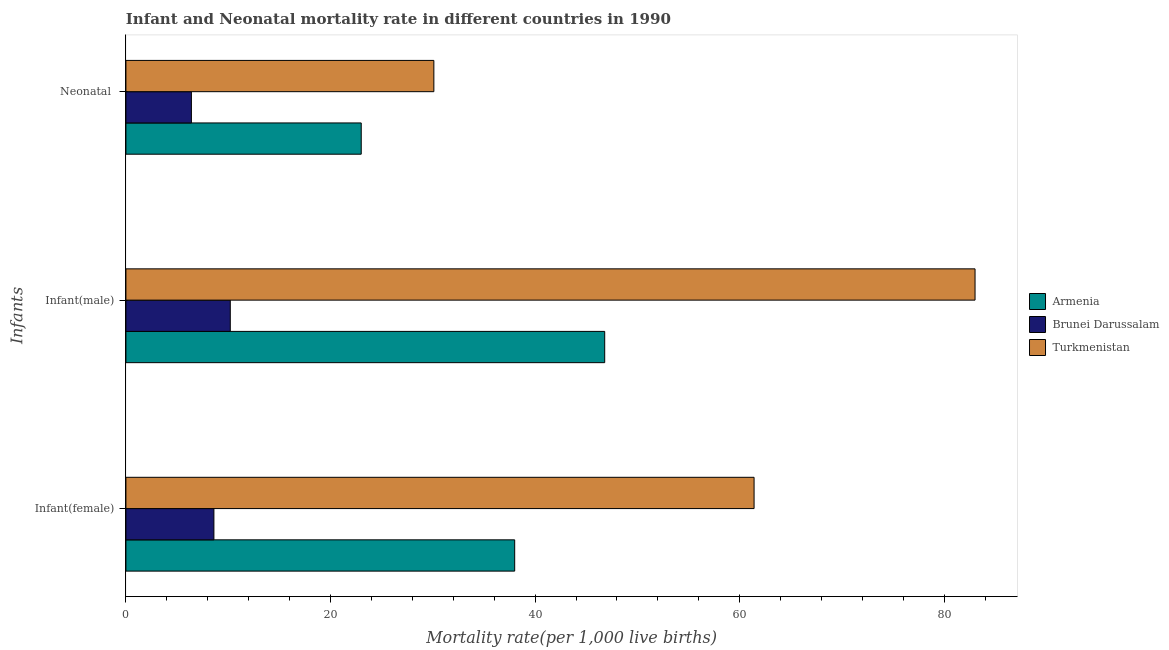How many different coloured bars are there?
Ensure brevity in your answer.  3. Are the number of bars on each tick of the Y-axis equal?
Provide a succinct answer. Yes. How many bars are there on the 2nd tick from the top?
Offer a terse response. 3. How many bars are there on the 2nd tick from the bottom?
Your answer should be very brief. 3. What is the label of the 1st group of bars from the top?
Provide a succinct answer. Neonatal . What is the infant mortality rate(female) in Turkmenistan?
Offer a terse response. 61.4. Across all countries, what is the maximum infant mortality rate(female)?
Make the answer very short. 61.4. Across all countries, what is the minimum neonatal mortality rate?
Ensure brevity in your answer.  6.4. In which country was the neonatal mortality rate maximum?
Make the answer very short. Turkmenistan. In which country was the infant mortality rate(male) minimum?
Keep it short and to the point. Brunei Darussalam. What is the total neonatal mortality rate in the graph?
Ensure brevity in your answer.  59.5. What is the difference between the infant mortality rate(female) in Brunei Darussalam and that in Armenia?
Your response must be concise. -29.4. What is the difference between the infant mortality rate(female) in Armenia and the infant mortality rate(male) in Brunei Darussalam?
Offer a very short reply. 27.8. What is the average neonatal mortality rate per country?
Offer a very short reply. 19.83. What is the difference between the neonatal mortality rate and infant mortality rate(female) in Brunei Darussalam?
Keep it short and to the point. -2.2. In how many countries, is the infant mortality rate(male) greater than 64 ?
Provide a short and direct response. 1. What is the ratio of the infant mortality rate(female) in Armenia to that in Brunei Darussalam?
Your response must be concise. 4.42. Is the difference between the neonatal mortality rate in Turkmenistan and Brunei Darussalam greater than the difference between the infant mortality rate(male) in Turkmenistan and Brunei Darussalam?
Ensure brevity in your answer.  No. What is the difference between the highest and the second highest infant mortality rate(male)?
Offer a terse response. 36.2. What is the difference between the highest and the lowest neonatal mortality rate?
Offer a terse response. 23.7. Is the sum of the infant mortality rate(male) in Armenia and Brunei Darussalam greater than the maximum neonatal mortality rate across all countries?
Your answer should be compact. Yes. What does the 1st bar from the top in Neonatal  represents?
Give a very brief answer. Turkmenistan. What does the 3rd bar from the bottom in Neonatal  represents?
Keep it short and to the point. Turkmenistan. How many bars are there?
Provide a succinct answer. 9. Are all the bars in the graph horizontal?
Your response must be concise. Yes. How many countries are there in the graph?
Make the answer very short. 3. What is the title of the graph?
Give a very brief answer. Infant and Neonatal mortality rate in different countries in 1990. What is the label or title of the X-axis?
Your answer should be compact. Mortality rate(per 1,0 live births). What is the label or title of the Y-axis?
Give a very brief answer. Infants. What is the Mortality rate(per 1,000 live births) of Armenia in Infant(female)?
Ensure brevity in your answer.  38. What is the Mortality rate(per 1,000 live births) in Turkmenistan in Infant(female)?
Provide a succinct answer. 61.4. What is the Mortality rate(per 1,000 live births) of Armenia in Infant(male)?
Ensure brevity in your answer.  46.8. What is the Mortality rate(per 1,000 live births) in Brunei Darussalam in Infant(male)?
Give a very brief answer. 10.2. What is the Mortality rate(per 1,000 live births) of Armenia in Neonatal ?
Offer a very short reply. 23. What is the Mortality rate(per 1,000 live births) in Brunei Darussalam in Neonatal ?
Make the answer very short. 6.4. What is the Mortality rate(per 1,000 live births) of Turkmenistan in Neonatal ?
Make the answer very short. 30.1. Across all Infants, what is the maximum Mortality rate(per 1,000 live births) of Armenia?
Your response must be concise. 46.8. Across all Infants, what is the maximum Mortality rate(per 1,000 live births) of Brunei Darussalam?
Provide a short and direct response. 10.2. Across all Infants, what is the maximum Mortality rate(per 1,000 live births) in Turkmenistan?
Provide a succinct answer. 83. Across all Infants, what is the minimum Mortality rate(per 1,000 live births) of Turkmenistan?
Provide a succinct answer. 30.1. What is the total Mortality rate(per 1,000 live births) of Armenia in the graph?
Keep it short and to the point. 107.8. What is the total Mortality rate(per 1,000 live births) in Brunei Darussalam in the graph?
Your answer should be very brief. 25.2. What is the total Mortality rate(per 1,000 live births) of Turkmenistan in the graph?
Make the answer very short. 174.5. What is the difference between the Mortality rate(per 1,000 live births) in Turkmenistan in Infant(female) and that in Infant(male)?
Your answer should be compact. -21.6. What is the difference between the Mortality rate(per 1,000 live births) in Turkmenistan in Infant(female) and that in Neonatal ?
Give a very brief answer. 31.3. What is the difference between the Mortality rate(per 1,000 live births) in Armenia in Infant(male) and that in Neonatal ?
Make the answer very short. 23.8. What is the difference between the Mortality rate(per 1,000 live births) in Turkmenistan in Infant(male) and that in Neonatal ?
Provide a short and direct response. 52.9. What is the difference between the Mortality rate(per 1,000 live births) of Armenia in Infant(female) and the Mortality rate(per 1,000 live births) of Brunei Darussalam in Infant(male)?
Offer a terse response. 27.8. What is the difference between the Mortality rate(per 1,000 live births) of Armenia in Infant(female) and the Mortality rate(per 1,000 live births) of Turkmenistan in Infant(male)?
Give a very brief answer. -45. What is the difference between the Mortality rate(per 1,000 live births) in Brunei Darussalam in Infant(female) and the Mortality rate(per 1,000 live births) in Turkmenistan in Infant(male)?
Make the answer very short. -74.4. What is the difference between the Mortality rate(per 1,000 live births) in Armenia in Infant(female) and the Mortality rate(per 1,000 live births) in Brunei Darussalam in Neonatal ?
Offer a terse response. 31.6. What is the difference between the Mortality rate(per 1,000 live births) in Brunei Darussalam in Infant(female) and the Mortality rate(per 1,000 live births) in Turkmenistan in Neonatal ?
Give a very brief answer. -21.5. What is the difference between the Mortality rate(per 1,000 live births) in Armenia in Infant(male) and the Mortality rate(per 1,000 live births) in Brunei Darussalam in Neonatal ?
Your answer should be very brief. 40.4. What is the difference between the Mortality rate(per 1,000 live births) of Armenia in Infant(male) and the Mortality rate(per 1,000 live births) of Turkmenistan in Neonatal ?
Your answer should be very brief. 16.7. What is the difference between the Mortality rate(per 1,000 live births) of Brunei Darussalam in Infant(male) and the Mortality rate(per 1,000 live births) of Turkmenistan in Neonatal ?
Provide a succinct answer. -19.9. What is the average Mortality rate(per 1,000 live births) of Armenia per Infants?
Your answer should be very brief. 35.93. What is the average Mortality rate(per 1,000 live births) of Turkmenistan per Infants?
Your answer should be compact. 58.17. What is the difference between the Mortality rate(per 1,000 live births) of Armenia and Mortality rate(per 1,000 live births) of Brunei Darussalam in Infant(female)?
Make the answer very short. 29.4. What is the difference between the Mortality rate(per 1,000 live births) of Armenia and Mortality rate(per 1,000 live births) of Turkmenistan in Infant(female)?
Keep it short and to the point. -23.4. What is the difference between the Mortality rate(per 1,000 live births) in Brunei Darussalam and Mortality rate(per 1,000 live births) in Turkmenistan in Infant(female)?
Make the answer very short. -52.8. What is the difference between the Mortality rate(per 1,000 live births) in Armenia and Mortality rate(per 1,000 live births) in Brunei Darussalam in Infant(male)?
Offer a very short reply. 36.6. What is the difference between the Mortality rate(per 1,000 live births) of Armenia and Mortality rate(per 1,000 live births) of Turkmenistan in Infant(male)?
Your answer should be very brief. -36.2. What is the difference between the Mortality rate(per 1,000 live births) in Brunei Darussalam and Mortality rate(per 1,000 live births) in Turkmenistan in Infant(male)?
Keep it short and to the point. -72.8. What is the difference between the Mortality rate(per 1,000 live births) of Armenia and Mortality rate(per 1,000 live births) of Brunei Darussalam in Neonatal ?
Keep it short and to the point. 16.6. What is the difference between the Mortality rate(per 1,000 live births) in Brunei Darussalam and Mortality rate(per 1,000 live births) in Turkmenistan in Neonatal ?
Your answer should be compact. -23.7. What is the ratio of the Mortality rate(per 1,000 live births) of Armenia in Infant(female) to that in Infant(male)?
Provide a succinct answer. 0.81. What is the ratio of the Mortality rate(per 1,000 live births) in Brunei Darussalam in Infant(female) to that in Infant(male)?
Your response must be concise. 0.84. What is the ratio of the Mortality rate(per 1,000 live births) of Turkmenistan in Infant(female) to that in Infant(male)?
Make the answer very short. 0.74. What is the ratio of the Mortality rate(per 1,000 live births) in Armenia in Infant(female) to that in Neonatal ?
Ensure brevity in your answer.  1.65. What is the ratio of the Mortality rate(per 1,000 live births) of Brunei Darussalam in Infant(female) to that in Neonatal ?
Your answer should be very brief. 1.34. What is the ratio of the Mortality rate(per 1,000 live births) of Turkmenistan in Infant(female) to that in Neonatal ?
Your answer should be very brief. 2.04. What is the ratio of the Mortality rate(per 1,000 live births) of Armenia in Infant(male) to that in Neonatal ?
Offer a terse response. 2.03. What is the ratio of the Mortality rate(per 1,000 live births) in Brunei Darussalam in Infant(male) to that in Neonatal ?
Offer a very short reply. 1.59. What is the ratio of the Mortality rate(per 1,000 live births) in Turkmenistan in Infant(male) to that in Neonatal ?
Provide a short and direct response. 2.76. What is the difference between the highest and the second highest Mortality rate(per 1,000 live births) in Turkmenistan?
Provide a short and direct response. 21.6. What is the difference between the highest and the lowest Mortality rate(per 1,000 live births) in Armenia?
Your answer should be compact. 23.8. What is the difference between the highest and the lowest Mortality rate(per 1,000 live births) in Turkmenistan?
Your answer should be very brief. 52.9. 